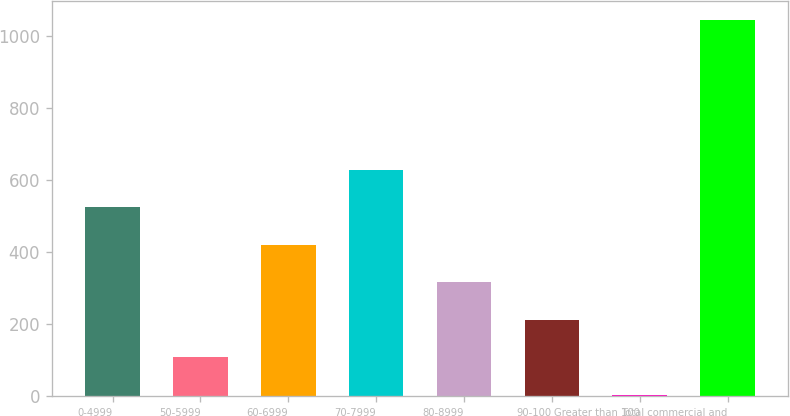<chart> <loc_0><loc_0><loc_500><loc_500><bar_chart><fcel>0-4999<fcel>50-5999<fcel>60-6999<fcel>70-7999<fcel>80-8999<fcel>90-100<fcel>Greater than 100<fcel>Total commercial and<nl><fcel>524.2<fcel>108.36<fcel>420.24<fcel>628.16<fcel>316.28<fcel>212.32<fcel>4.4<fcel>1044<nl></chart> 